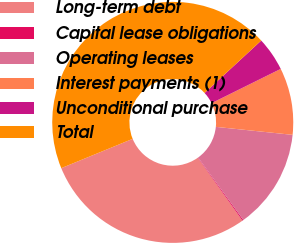<chart> <loc_0><loc_0><loc_500><loc_500><pie_chart><fcel>Long-term debt<fcel>Capital lease obligations<fcel>Operating leases<fcel>Interest payments (1)<fcel>Unconditional purchase<fcel>Total<nl><fcel>28.62%<fcel>0.14%<fcel>13.39%<fcel>8.97%<fcel>4.56%<fcel>44.32%<nl></chart> 